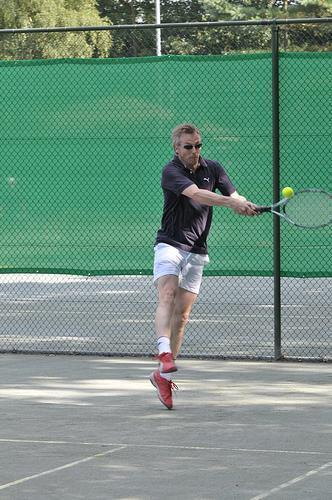How many people are visible?
Give a very brief answer. 1. How many dark umbrellas are there?
Give a very brief answer. 0. 